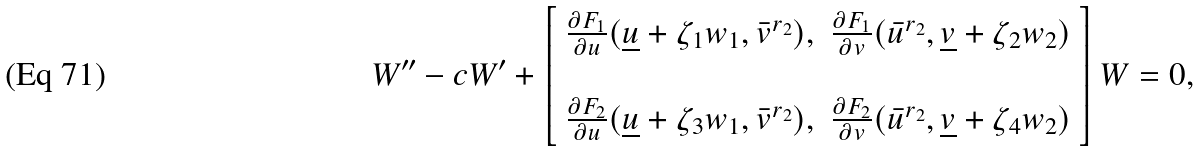Convert formula to latex. <formula><loc_0><loc_0><loc_500><loc_500>W ^ { \prime \prime } - c W ^ { \prime } + \left [ \begin{array} { c c } \frac { \partial F _ { 1 } } { \partial u } ( \underline { u } + \zeta _ { 1 } w _ { 1 } , \bar { v } ^ { r _ { 2 } } ) , & \frac { \partial F _ { 1 } } { \partial v } ( \bar { u } ^ { r _ { 2 } } , \underline { v } + \zeta _ { 2 } w _ { 2 } ) \\ \\ \frac { \partial F _ { 2 } } { \partial u } ( \underline { u } + \zeta _ { 3 } w _ { 1 } , \bar { v } ^ { r _ { 2 } } ) , & \frac { \partial F _ { 2 } } { \partial v } ( \bar { u } ^ { r _ { 2 } } , \underline { v } + \zeta _ { 4 } w _ { 2 } ) \end{array} \right ] W = 0 ,</formula> 